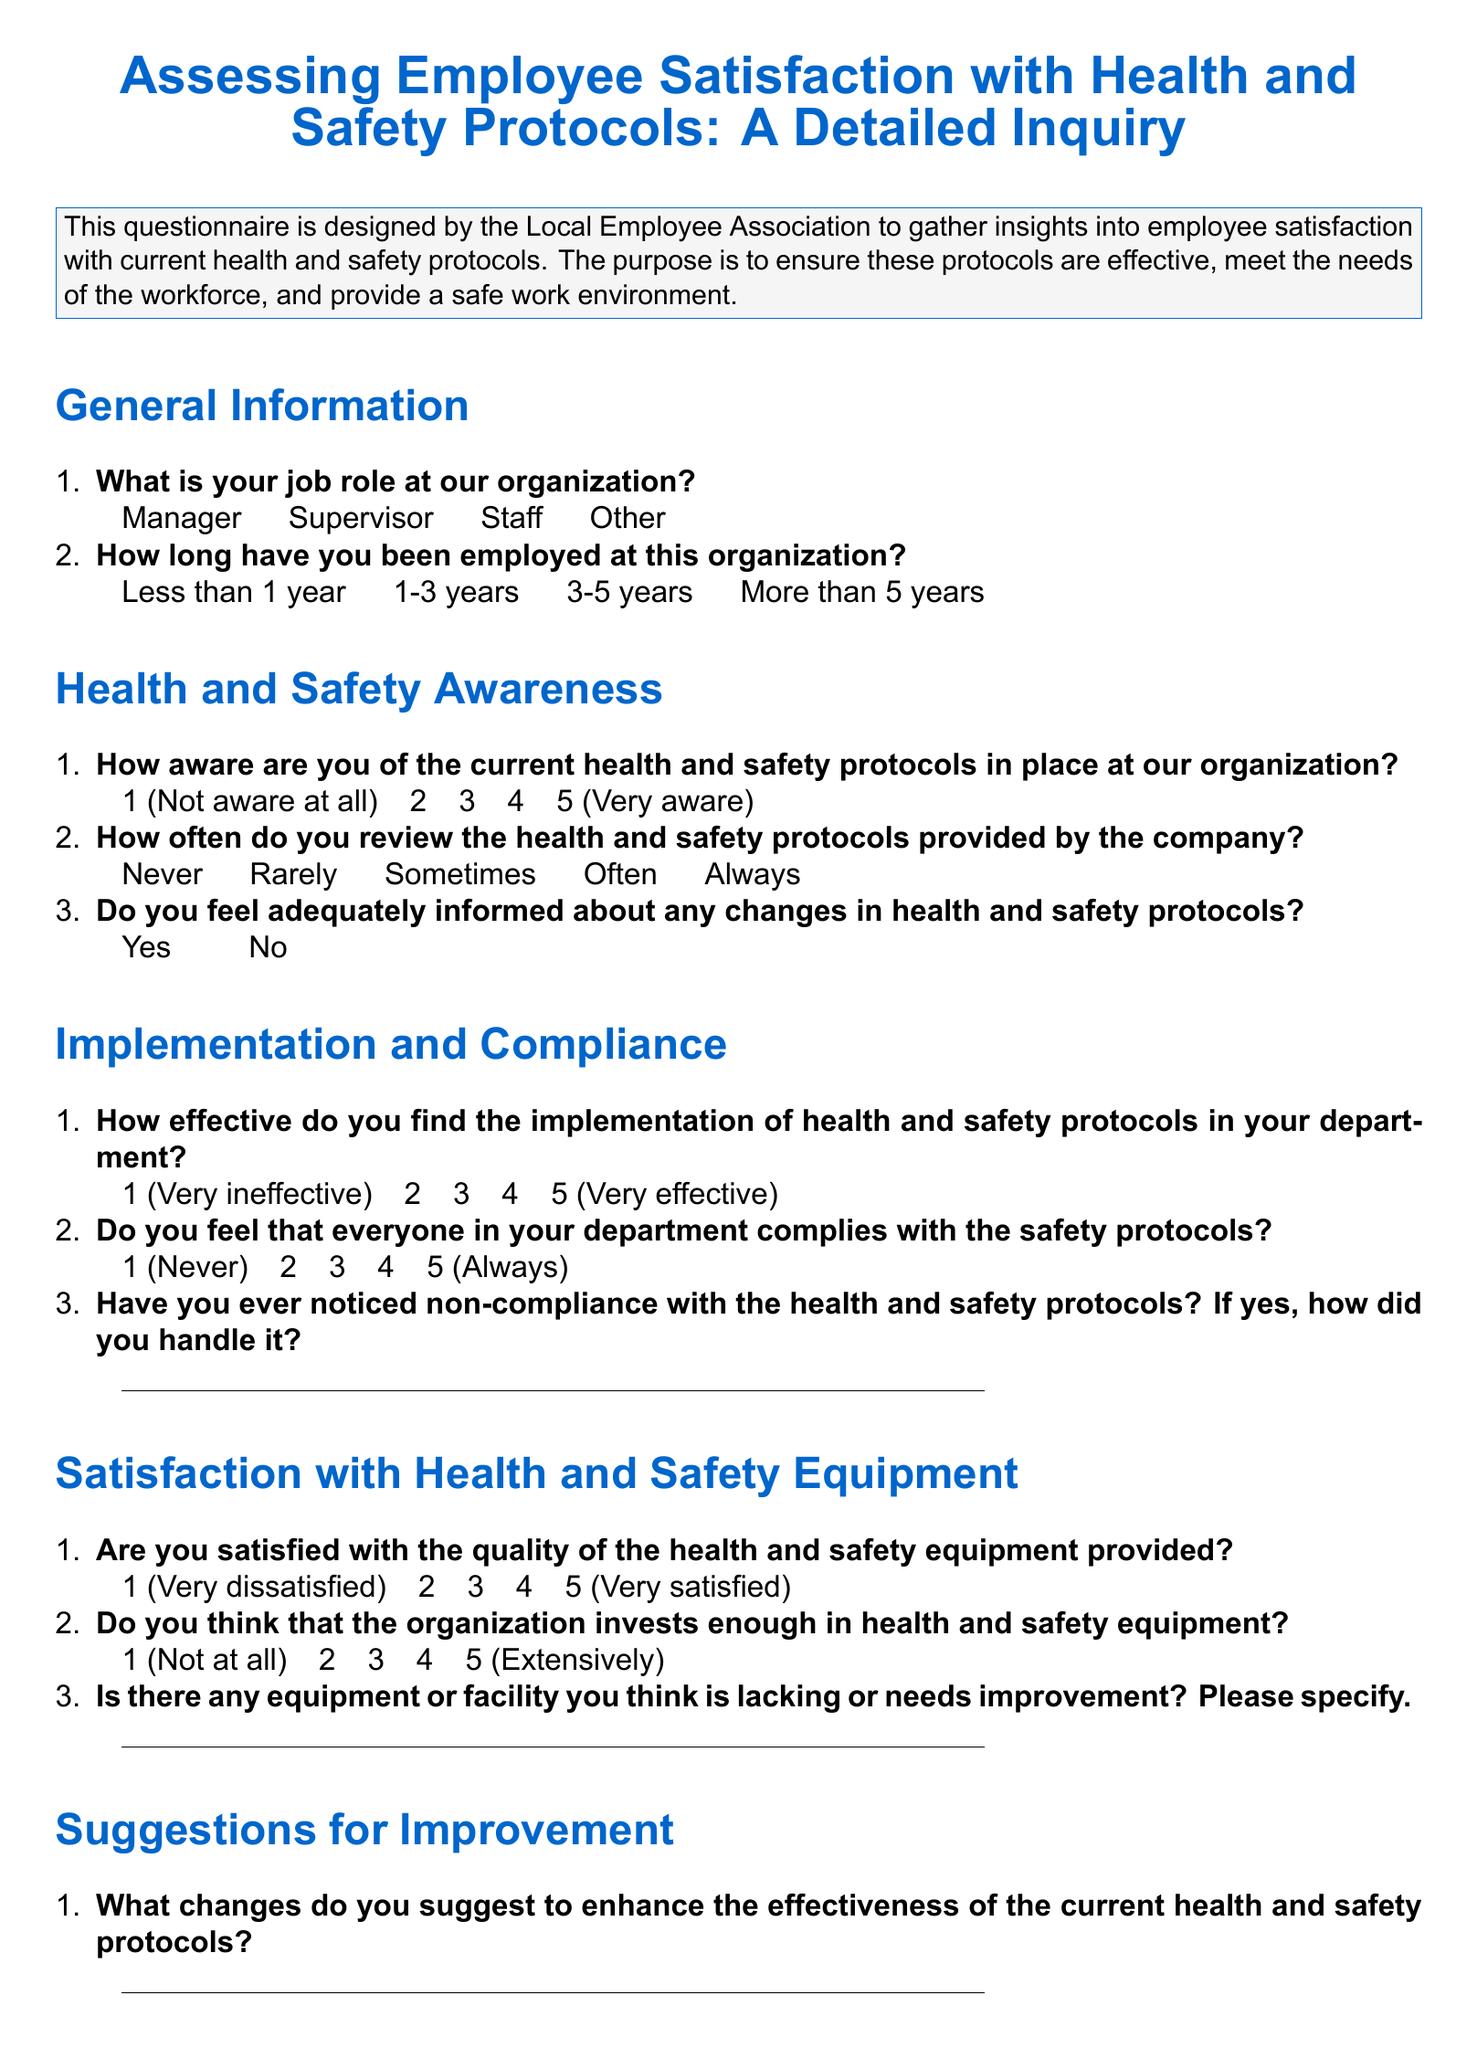What is the title of the questionnaire? The title of the questionnaire is presented prominently at the top of the document.
Answer: Assessing Employee Satisfaction with Health and Safety Protocols: A Detailed Inquiry How many sections are in the questionnaire? The questionnaire is divided into multiple sections, each addressing different aspects of health and safety.
Answer: Five What is one of the job roles listed in the general information section? The job roles that respondents can select from are specified in the general information section.
Answer: Supervisor How satisfied are employees with the health and safety equipment provided? The level of satisfaction with health and safety equipment is measured on a scale from 1 to 5.
Answer: 1 (Very dissatisfied) to 5 (Very satisfied) What is the range of employment duration options provided? The document specifies different ranges for how long employees have been employed.
Answer: Less than 1 year to More than 5 years What should be specified regarding lacking or improving equipment? The questionnaire asks for employee input on areas needing improvement, inviting specific responses.
Answer: Equipment or facility How do employees indicate their awareness of health and safety protocols? Awareness is measured on a scale provided in the questionnaire.
Answer: 1 (Not aware at all) to 5 (Very aware) Do the employees feel adequately informed about changes in health and safety protocols? This question allows a simple affirmative or negative response from employees.
Answer: Yes or No What options are given for reviewing health and safety protocols frequency? Options describe the frequency of reviewing protocols, ranging from never to always.
Answer: Never to Always 